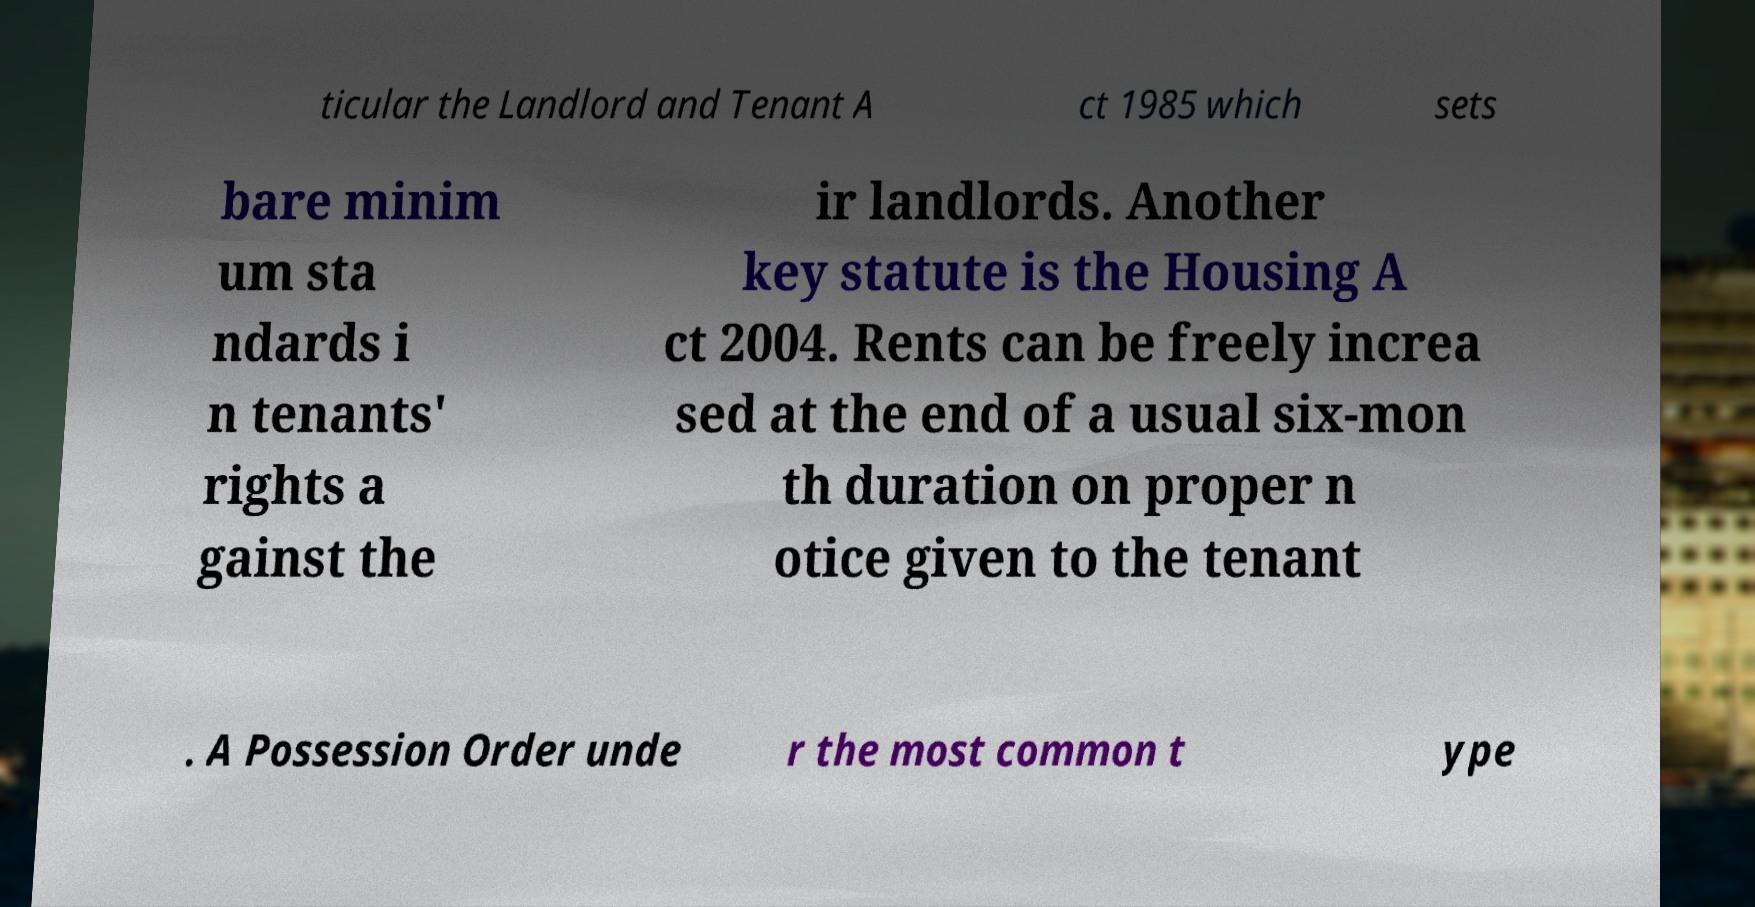Please read and relay the text visible in this image. What does it say? ticular the Landlord and Tenant A ct 1985 which sets bare minim um sta ndards i n tenants' rights a gainst the ir landlords. Another key statute is the Housing A ct 2004. Rents can be freely increa sed at the end of a usual six-mon th duration on proper n otice given to the tenant . A Possession Order unde r the most common t ype 